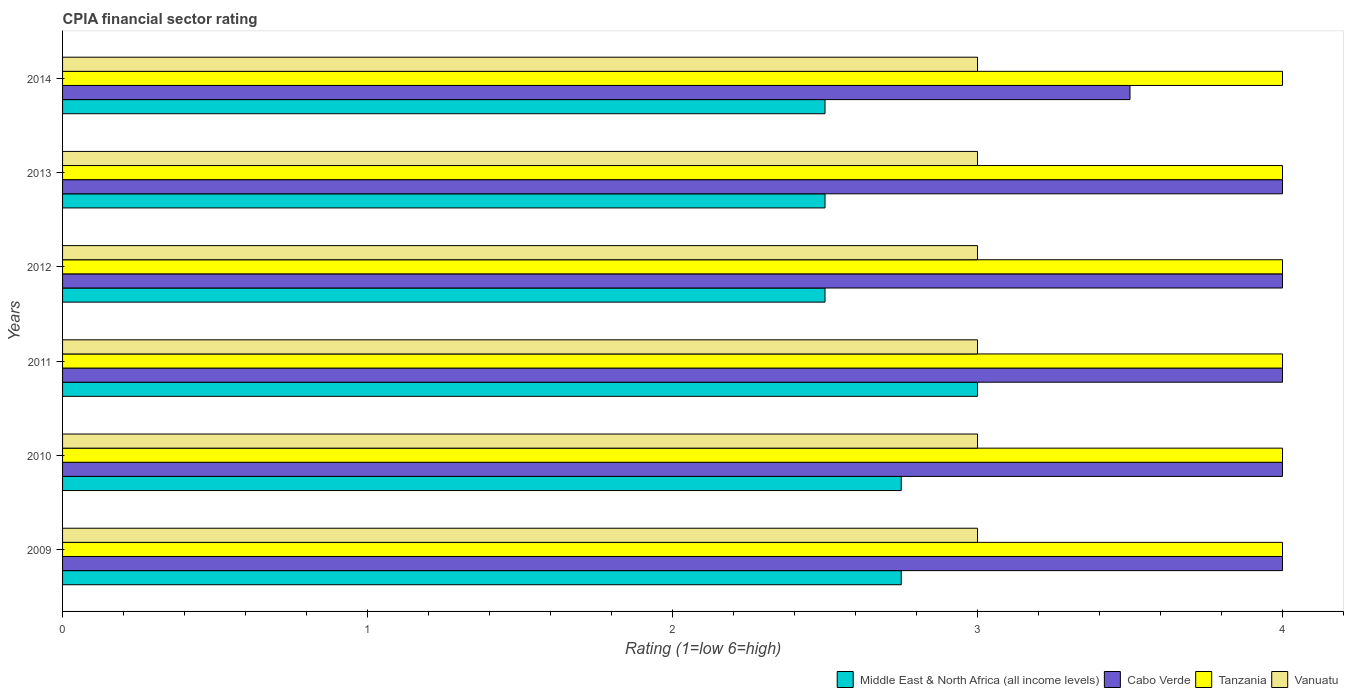Are the number of bars per tick equal to the number of legend labels?
Provide a short and direct response. Yes. How many bars are there on the 2nd tick from the bottom?
Provide a short and direct response. 4. What is the label of the 2nd group of bars from the top?
Offer a very short reply. 2013. Across all years, what is the maximum CPIA rating in Tanzania?
Your answer should be very brief. 4. In which year was the CPIA rating in Middle East & North Africa (all income levels) maximum?
Your answer should be very brief. 2011. What is the total CPIA rating in Tanzania in the graph?
Your response must be concise. 24. What is the average CPIA rating in Middle East & North Africa (all income levels) per year?
Give a very brief answer. 2.67. In the year 2009, what is the difference between the CPIA rating in Vanuatu and CPIA rating in Tanzania?
Your response must be concise. -1. Is the CPIA rating in Middle East & North Africa (all income levels) in 2011 less than that in 2013?
Provide a short and direct response. No. What is the difference between the highest and the lowest CPIA rating in Tanzania?
Make the answer very short. 0. What does the 2nd bar from the top in 2013 represents?
Offer a terse response. Tanzania. What does the 1st bar from the bottom in 2011 represents?
Ensure brevity in your answer.  Middle East & North Africa (all income levels). How many years are there in the graph?
Make the answer very short. 6. Are the values on the major ticks of X-axis written in scientific E-notation?
Keep it short and to the point. No. Does the graph contain any zero values?
Your answer should be compact. No. How many legend labels are there?
Provide a succinct answer. 4. How are the legend labels stacked?
Your answer should be very brief. Horizontal. What is the title of the graph?
Your response must be concise. CPIA financial sector rating. What is the label or title of the X-axis?
Make the answer very short. Rating (1=low 6=high). What is the label or title of the Y-axis?
Make the answer very short. Years. What is the Rating (1=low 6=high) of Middle East & North Africa (all income levels) in 2009?
Keep it short and to the point. 2.75. What is the Rating (1=low 6=high) of Tanzania in 2009?
Make the answer very short. 4. What is the Rating (1=low 6=high) of Vanuatu in 2009?
Provide a short and direct response. 3. What is the Rating (1=low 6=high) in Middle East & North Africa (all income levels) in 2010?
Provide a succinct answer. 2.75. What is the Rating (1=low 6=high) of Cabo Verde in 2010?
Ensure brevity in your answer.  4. What is the Rating (1=low 6=high) of Vanuatu in 2010?
Offer a terse response. 3. What is the Rating (1=low 6=high) of Cabo Verde in 2011?
Make the answer very short. 4. What is the Rating (1=low 6=high) in Tanzania in 2011?
Your answer should be very brief. 4. What is the Rating (1=low 6=high) in Vanuatu in 2011?
Provide a short and direct response. 3. What is the Rating (1=low 6=high) of Vanuatu in 2012?
Your response must be concise. 3. What is the Rating (1=low 6=high) in Middle East & North Africa (all income levels) in 2013?
Give a very brief answer. 2.5. What is the Rating (1=low 6=high) in Cabo Verde in 2013?
Ensure brevity in your answer.  4. Across all years, what is the maximum Rating (1=low 6=high) of Middle East & North Africa (all income levels)?
Offer a very short reply. 3. Across all years, what is the maximum Rating (1=low 6=high) of Cabo Verde?
Provide a succinct answer. 4. Across all years, what is the maximum Rating (1=low 6=high) in Tanzania?
Your answer should be very brief. 4. Across all years, what is the maximum Rating (1=low 6=high) in Vanuatu?
Your answer should be compact. 3. Across all years, what is the minimum Rating (1=low 6=high) of Cabo Verde?
Make the answer very short. 3.5. What is the total Rating (1=low 6=high) of Cabo Verde in the graph?
Give a very brief answer. 23.5. What is the difference between the Rating (1=low 6=high) of Tanzania in 2009 and that in 2011?
Offer a very short reply. 0. What is the difference between the Rating (1=low 6=high) in Middle East & North Africa (all income levels) in 2009 and that in 2012?
Your answer should be compact. 0.25. What is the difference between the Rating (1=low 6=high) of Tanzania in 2009 and that in 2012?
Make the answer very short. 0. What is the difference between the Rating (1=low 6=high) of Vanuatu in 2009 and that in 2012?
Make the answer very short. 0. What is the difference between the Rating (1=low 6=high) of Middle East & North Africa (all income levels) in 2009 and that in 2013?
Offer a terse response. 0.25. What is the difference between the Rating (1=low 6=high) of Vanuatu in 2009 and that in 2013?
Provide a short and direct response. 0. What is the difference between the Rating (1=low 6=high) in Cabo Verde in 2009 and that in 2014?
Offer a very short reply. 0.5. What is the difference between the Rating (1=low 6=high) of Vanuatu in 2009 and that in 2014?
Your answer should be very brief. 0. What is the difference between the Rating (1=low 6=high) in Middle East & North Africa (all income levels) in 2010 and that in 2011?
Offer a very short reply. -0.25. What is the difference between the Rating (1=low 6=high) in Vanuatu in 2010 and that in 2011?
Your response must be concise. 0. What is the difference between the Rating (1=low 6=high) of Middle East & North Africa (all income levels) in 2010 and that in 2012?
Ensure brevity in your answer.  0.25. What is the difference between the Rating (1=low 6=high) of Cabo Verde in 2010 and that in 2012?
Give a very brief answer. 0. What is the difference between the Rating (1=low 6=high) of Vanuatu in 2010 and that in 2012?
Provide a short and direct response. 0. What is the difference between the Rating (1=low 6=high) in Middle East & North Africa (all income levels) in 2010 and that in 2013?
Provide a short and direct response. 0.25. What is the difference between the Rating (1=low 6=high) of Tanzania in 2010 and that in 2013?
Keep it short and to the point. 0. What is the difference between the Rating (1=low 6=high) in Tanzania in 2010 and that in 2014?
Offer a very short reply. 0. What is the difference between the Rating (1=low 6=high) in Middle East & North Africa (all income levels) in 2011 and that in 2012?
Offer a terse response. 0.5. What is the difference between the Rating (1=low 6=high) in Vanuatu in 2011 and that in 2012?
Offer a terse response. 0. What is the difference between the Rating (1=low 6=high) of Middle East & North Africa (all income levels) in 2011 and that in 2013?
Provide a succinct answer. 0.5. What is the difference between the Rating (1=low 6=high) in Cabo Verde in 2011 and that in 2013?
Give a very brief answer. 0. What is the difference between the Rating (1=low 6=high) in Tanzania in 2011 and that in 2013?
Your answer should be compact. 0. What is the difference between the Rating (1=low 6=high) in Vanuatu in 2011 and that in 2014?
Offer a terse response. 0. What is the difference between the Rating (1=low 6=high) in Middle East & North Africa (all income levels) in 2012 and that in 2013?
Provide a succinct answer. 0. What is the difference between the Rating (1=low 6=high) of Cabo Verde in 2012 and that in 2013?
Make the answer very short. 0. What is the difference between the Rating (1=low 6=high) of Middle East & North Africa (all income levels) in 2012 and that in 2014?
Ensure brevity in your answer.  0. What is the difference between the Rating (1=low 6=high) of Vanuatu in 2013 and that in 2014?
Your answer should be very brief. 0. What is the difference between the Rating (1=low 6=high) in Middle East & North Africa (all income levels) in 2009 and the Rating (1=low 6=high) in Cabo Verde in 2010?
Give a very brief answer. -1.25. What is the difference between the Rating (1=low 6=high) in Middle East & North Africa (all income levels) in 2009 and the Rating (1=low 6=high) in Tanzania in 2010?
Your answer should be compact. -1.25. What is the difference between the Rating (1=low 6=high) in Middle East & North Africa (all income levels) in 2009 and the Rating (1=low 6=high) in Vanuatu in 2010?
Provide a short and direct response. -0.25. What is the difference between the Rating (1=low 6=high) of Cabo Verde in 2009 and the Rating (1=low 6=high) of Tanzania in 2010?
Provide a succinct answer. 0. What is the difference between the Rating (1=low 6=high) of Middle East & North Africa (all income levels) in 2009 and the Rating (1=low 6=high) of Cabo Verde in 2011?
Keep it short and to the point. -1.25. What is the difference between the Rating (1=low 6=high) of Middle East & North Africa (all income levels) in 2009 and the Rating (1=low 6=high) of Tanzania in 2011?
Give a very brief answer. -1.25. What is the difference between the Rating (1=low 6=high) in Cabo Verde in 2009 and the Rating (1=low 6=high) in Tanzania in 2011?
Ensure brevity in your answer.  0. What is the difference between the Rating (1=low 6=high) of Cabo Verde in 2009 and the Rating (1=low 6=high) of Vanuatu in 2011?
Make the answer very short. 1. What is the difference between the Rating (1=low 6=high) in Tanzania in 2009 and the Rating (1=low 6=high) in Vanuatu in 2011?
Keep it short and to the point. 1. What is the difference between the Rating (1=low 6=high) of Middle East & North Africa (all income levels) in 2009 and the Rating (1=low 6=high) of Cabo Verde in 2012?
Give a very brief answer. -1.25. What is the difference between the Rating (1=low 6=high) in Middle East & North Africa (all income levels) in 2009 and the Rating (1=low 6=high) in Tanzania in 2012?
Give a very brief answer. -1.25. What is the difference between the Rating (1=low 6=high) of Middle East & North Africa (all income levels) in 2009 and the Rating (1=low 6=high) of Vanuatu in 2012?
Provide a succinct answer. -0.25. What is the difference between the Rating (1=low 6=high) in Cabo Verde in 2009 and the Rating (1=low 6=high) in Vanuatu in 2012?
Give a very brief answer. 1. What is the difference between the Rating (1=low 6=high) of Middle East & North Africa (all income levels) in 2009 and the Rating (1=low 6=high) of Cabo Verde in 2013?
Your response must be concise. -1.25. What is the difference between the Rating (1=low 6=high) of Middle East & North Africa (all income levels) in 2009 and the Rating (1=low 6=high) of Tanzania in 2013?
Offer a very short reply. -1.25. What is the difference between the Rating (1=low 6=high) of Middle East & North Africa (all income levels) in 2009 and the Rating (1=low 6=high) of Vanuatu in 2013?
Give a very brief answer. -0.25. What is the difference between the Rating (1=low 6=high) in Cabo Verde in 2009 and the Rating (1=low 6=high) in Tanzania in 2013?
Your answer should be very brief. 0. What is the difference between the Rating (1=low 6=high) of Middle East & North Africa (all income levels) in 2009 and the Rating (1=low 6=high) of Cabo Verde in 2014?
Your response must be concise. -0.75. What is the difference between the Rating (1=low 6=high) of Middle East & North Africa (all income levels) in 2009 and the Rating (1=low 6=high) of Tanzania in 2014?
Offer a very short reply. -1.25. What is the difference between the Rating (1=low 6=high) in Cabo Verde in 2009 and the Rating (1=low 6=high) in Vanuatu in 2014?
Provide a succinct answer. 1. What is the difference between the Rating (1=low 6=high) of Middle East & North Africa (all income levels) in 2010 and the Rating (1=low 6=high) of Cabo Verde in 2011?
Keep it short and to the point. -1.25. What is the difference between the Rating (1=low 6=high) of Middle East & North Africa (all income levels) in 2010 and the Rating (1=low 6=high) of Tanzania in 2011?
Provide a succinct answer. -1.25. What is the difference between the Rating (1=low 6=high) of Middle East & North Africa (all income levels) in 2010 and the Rating (1=low 6=high) of Vanuatu in 2011?
Make the answer very short. -0.25. What is the difference between the Rating (1=low 6=high) of Cabo Verde in 2010 and the Rating (1=low 6=high) of Tanzania in 2011?
Provide a succinct answer. 0. What is the difference between the Rating (1=low 6=high) of Cabo Verde in 2010 and the Rating (1=low 6=high) of Vanuatu in 2011?
Make the answer very short. 1. What is the difference between the Rating (1=low 6=high) of Middle East & North Africa (all income levels) in 2010 and the Rating (1=low 6=high) of Cabo Verde in 2012?
Provide a short and direct response. -1.25. What is the difference between the Rating (1=low 6=high) of Middle East & North Africa (all income levels) in 2010 and the Rating (1=low 6=high) of Tanzania in 2012?
Your answer should be compact. -1.25. What is the difference between the Rating (1=low 6=high) in Cabo Verde in 2010 and the Rating (1=low 6=high) in Tanzania in 2012?
Make the answer very short. 0. What is the difference between the Rating (1=low 6=high) in Tanzania in 2010 and the Rating (1=low 6=high) in Vanuatu in 2012?
Ensure brevity in your answer.  1. What is the difference between the Rating (1=low 6=high) of Middle East & North Africa (all income levels) in 2010 and the Rating (1=low 6=high) of Cabo Verde in 2013?
Give a very brief answer. -1.25. What is the difference between the Rating (1=low 6=high) of Middle East & North Africa (all income levels) in 2010 and the Rating (1=low 6=high) of Tanzania in 2013?
Give a very brief answer. -1.25. What is the difference between the Rating (1=low 6=high) in Middle East & North Africa (all income levels) in 2010 and the Rating (1=low 6=high) in Vanuatu in 2013?
Your answer should be compact. -0.25. What is the difference between the Rating (1=low 6=high) in Cabo Verde in 2010 and the Rating (1=low 6=high) in Tanzania in 2013?
Provide a succinct answer. 0. What is the difference between the Rating (1=low 6=high) of Cabo Verde in 2010 and the Rating (1=low 6=high) of Vanuatu in 2013?
Your answer should be compact. 1. What is the difference between the Rating (1=low 6=high) of Tanzania in 2010 and the Rating (1=low 6=high) of Vanuatu in 2013?
Give a very brief answer. 1. What is the difference between the Rating (1=low 6=high) of Middle East & North Africa (all income levels) in 2010 and the Rating (1=low 6=high) of Cabo Verde in 2014?
Offer a very short reply. -0.75. What is the difference between the Rating (1=low 6=high) of Middle East & North Africa (all income levels) in 2010 and the Rating (1=low 6=high) of Tanzania in 2014?
Your response must be concise. -1.25. What is the difference between the Rating (1=low 6=high) in Cabo Verde in 2010 and the Rating (1=low 6=high) in Tanzania in 2014?
Provide a succinct answer. 0. What is the difference between the Rating (1=low 6=high) of Cabo Verde in 2010 and the Rating (1=low 6=high) of Vanuatu in 2014?
Provide a succinct answer. 1. What is the difference between the Rating (1=low 6=high) of Tanzania in 2010 and the Rating (1=low 6=high) of Vanuatu in 2014?
Your answer should be very brief. 1. What is the difference between the Rating (1=low 6=high) of Middle East & North Africa (all income levels) in 2011 and the Rating (1=low 6=high) of Cabo Verde in 2012?
Offer a terse response. -1. What is the difference between the Rating (1=low 6=high) in Middle East & North Africa (all income levels) in 2011 and the Rating (1=low 6=high) in Tanzania in 2012?
Your response must be concise. -1. What is the difference between the Rating (1=low 6=high) in Middle East & North Africa (all income levels) in 2011 and the Rating (1=low 6=high) in Vanuatu in 2012?
Keep it short and to the point. 0. What is the difference between the Rating (1=low 6=high) of Cabo Verde in 2011 and the Rating (1=low 6=high) of Vanuatu in 2012?
Provide a succinct answer. 1. What is the difference between the Rating (1=low 6=high) in Tanzania in 2011 and the Rating (1=low 6=high) in Vanuatu in 2012?
Offer a terse response. 1. What is the difference between the Rating (1=low 6=high) of Middle East & North Africa (all income levels) in 2011 and the Rating (1=low 6=high) of Cabo Verde in 2013?
Provide a short and direct response. -1. What is the difference between the Rating (1=low 6=high) in Middle East & North Africa (all income levels) in 2011 and the Rating (1=low 6=high) in Tanzania in 2013?
Your answer should be compact. -1. What is the difference between the Rating (1=low 6=high) in Cabo Verde in 2011 and the Rating (1=low 6=high) in Tanzania in 2013?
Give a very brief answer. 0. What is the difference between the Rating (1=low 6=high) in Middle East & North Africa (all income levels) in 2011 and the Rating (1=low 6=high) in Cabo Verde in 2014?
Ensure brevity in your answer.  -0.5. What is the difference between the Rating (1=low 6=high) of Middle East & North Africa (all income levels) in 2011 and the Rating (1=low 6=high) of Tanzania in 2014?
Ensure brevity in your answer.  -1. What is the difference between the Rating (1=low 6=high) of Cabo Verde in 2011 and the Rating (1=low 6=high) of Vanuatu in 2014?
Ensure brevity in your answer.  1. What is the difference between the Rating (1=low 6=high) in Tanzania in 2011 and the Rating (1=low 6=high) in Vanuatu in 2014?
Your answer should be compact. 1. What is the difference between the Rating (1=low 6=high) in Middle East & North Africa (all income levels) in 2012 and the Rating (1=low 6=high) in Cabo Verde in 2013?
Your answer should be very brief. -1.5. What is the difference between the Rating (1=low 6=high) of Middle East & North Africa (all income levels) in 2012 and the Rating (1=low 6=high) of Vanuatu in 2013?
Your response must be concise. -0.5. What is the difference between the Rating (1=low 6=high) in Tanzania in 2012 and the Rating (1=low 6=high) in Vanuatu in 2013?
Your response must be concise. 1. What is the difference between the Rating (1=low 6=high) of Middle East & North Africa (all income levels) in 2012 and the Rating (1=low 6=high) of Cabo Verde in 2014?
Your answer should be compact. -1. What is the difference between the Rating (1=low 6=high) in Middle East & North Africa (all income levels) in 2012 and the Rating (1=low 6=high) in Tanzania in 2014?
Your answer should be compact. -1.5. What is the difference between the Rating (1=low 6=high) in Cabo Verde in 2012 and the Rating (1=low 6=high) in Tanzania in 2014?
Provide a succinct answer. 0. What is the difference between the Rating (1=low 6=high) in Cabo Verde in 2012 and the Rating (1=low 6=high) in Vanuatu in 2014?
Your response must be concise. 1. What is the difference between the Rating (1=low 6=high) of Tanzania in 2012 and the Rating (1=low 6=high) of Vanuatu in 2014?
Your response must be concise. 1. What is the difference between the Rating (1=low 6=high) in Middle East & North Africa (all income levels) in 2013 and the Rating (1=low 6=high) in Cabo Verde in 2014?
Offer a terse response. -1. What is the difference between the Rating (1=low 6=high) of Cabo Verde in 2013 and the Rating (1=low 6=high) of Tanzania in 2014?
Offer a very short reply. 0. What is the difference between the Rating (1=low 6=high) of Tanzania in 2013 and the Rating (1=low 6=high) of Vanuatu in 2014?
Provide a succinct answer. 1. What is the average Rating (1=low 6=high) of Middle East & North Africa (all income levels) per year?
Ensure brevity in your answer.  2.67. What is the average Rating (1=low 6=high) of Cabo Verde per year?
Provide a short and direct response. 3.92. What is the average Rating (1=low 6=high) of Tanzania per year?
Provide a succinct answer. 4. In the year 2009, what is the difference between the Rating (1=low 6=high) in Middle East & North Africa (all income levels) and Rating (1=low 6=high) in Cabo Verde?
Keep it short and to the point. -1.25. In the year 2009, what is the difference between the Rating (1=low 6=high) of Middle East & North Africa (all income levels) and Rating (1=low 6=high) of Tanzania?
Make the answer very short. -1.25. In the year 2010, what is the difference between the Rating (1=low 6=high) in Middle East & North Africa (all income levels) and Rating (1=low 6=high) in Cabo Verde?
Ensure brevity in your answer.  -1.25. In the year 2010, what is the difference between the Rating (1=low 6=high) of Middle East & North Africa (all income levels) and Rating (1=low 6=high) of Tanzania?
Offer a very short reply. -1.25. In the year 2010, what is the difference between the Rating (1=low 6=high) in Middle East & North Africa (all income levels) and Rating (1=low 6=high) in Vanuatu?
Your response must be concise. -0.25. In the year 2010, what is the difference between the Rating (1=low 6=high) in Cabo Verde and Rating (1=low 6=high) in Tanzania?
Offer a terse response. 0. In the year 2010, what is the difference between the Rating (1=low 6=high) of Tanzania and Rating (1=low 6=high) of Vanuatu?
Your answer should be compact. 1. In the year 2011, what is the difference between the Rating (1=low 6=high) in Middle East & North Africa (all income levels) and Rating (1=low 6=high) in Vanuatu?
Your response must be concise. 0. In the year 2011, what is the difference between the Rating (1=low 6=high) in Cabo Verde and Rating (1=low 6=high) in Vanuatu?
Ensure brevity in your answer.  1. In the year 2013, what is the difference between the Rating (1=low 6=high) of Middle East & North Africa (all income levels) and Rating (1=low 6=high) of Cabo Verde?
Your response must be concise. -1.5. In the year 2013, what is the difference between the Rating (1=low 6=high) of Middle East & North Africa (all income levels) and Rating (1=low 6=high) of Tanzania?
Offer a terse response. -1.5. In the year 2013, what is the difference between the Rating (1=low 6=high) of Middle East & North Africa (all income levels) and Rating (1=low 6=high) of Vanuatu?
Provide a succinct answer. -0.5. In the year 2014, what is the difference between the Rating (1=low 6=high) in Middle East & North Africa (all income levels) and Rating (1=low 6=high) in Vanuatu?
Offer a very short reply. -0.5. In the year 2014, what is the difference between the Rating (1=low 6=high) of Cabo Verde and Rating (1=low 6=high) of Tanzania?
Make the answer very short. -0.5. In the year 2014, what is the difference between the Rating (1=low 6=high) in Tanzania and Rating (1=low 6=high) in Vanuatu?
Your response must be concise. 1. What is the ratio of the Rating (1=low 6=high) in Middle East & North Africa (all income levels) in 2009 to that in 2010?
Your answer should be compact. 1. What is the ratio of the Rating (1=low 6=high) in Tanzania in 2009 to that in 2010?
Provide a succinct answer. 1. What is the ratio of the Rating (1=low 6=high) of Middle East & North Africa (all income levels) in 2009 to that in 2011?
Keep it short and to the point. 0.92. What is the ratio of the Rating (1=low 6=high) of Cabo Verde in 2009 to that in 2011?
Your answer should be compact. 1. What is the ratio of the Rating (1=low 6=high) in Tanzania in 2009 to that in 2011?
Your answer should be compact. 1. What is the ratio of the Rating (1=low 6=high) of Vanuatu in 2009 to that in 2011?
Make the answer very short. 1. What is the ratio of the Rating (1=low 6=high) of Cabo Verde in 2009 to that in 2012?
Ensure brevity in your answer.  1. What is the ratio of the Rating (1=low 6=high) in Vanuatu in 2009 to that in 2012?
Keep it short and to the point. 1. What is the ratio of the Rating (1=low 6=high) in Cabo Verde in 2009 to that in 2013?
Your answer should be very brief. 1. What is the ratio of the Rating (1=low 6=high) of Middle East & North Africa (all income levels) in 2009 to that in 2014?
Your answer should be very brief. 1.1. What is the ratio of the Rating (1=low 6=high) of Cabo Verde in 2009 to that in 2014?
Give a very brief answer. 1.14. What is the ratio of the Rating (1=low 6=high) in Tanzania in 2009 to that in 2014?
Your response must be concise. 1. What is the ratio of the Rating (1=low 6=high) of Vanuatu in 2009 to that in 2014?
Make the answer very short. 1. What is the ratio of the Rating (1=low 6=high) of Middle East & North Africa (all income levels) in 2010 to that in 2011?
Your response must be concise. 0.92. What is the ratio of the Rating (1=low 6=high) of Cabo Verde in 2010 to that in 2011?
Your response must be concise. 1. What is the ratio of the Rating (1=low 6=high) in Tanzania in 2010 to that in 2011?
Give a very brief answer. 1. What is the ratio of the Rating (1=low 6=high) in Vanuatu in 2010 to that in 2011?
Offer a very short reply. 1. What is the ratio of the Rating (1=low 6=high) of Middle East & North Africa (all income levels) in 2010 to that in 2013?
Offer a very short reply. 1.1. What is the ratio of the Rating (1=low 6=high) of Cabo Verde in 2010 to that in 2013?
Provide a succinct answer. 1. What is the ratio of the Rating (1=low 6=high) in Tanzania in 2010 to that in 2013?
Give a very brief answer. 1. What is the ratio of the Rating (1=low 6=high) of Vanuatu in 2010 to that in 2013?
Offer a very short reply. 1. What is the ratio of the Rating (1=low 6=high) of Middle East & North Africa (all income levels) in 2010 to that in 2014?
Your answer should be compact. 1.1. What is the ratio of the Rating (1=low 6=high) of Vanuatu in 2010 to that in 2014?
Provide a short and direct response. 1. What is the ratio of the Rating (1=low 6=high) in Middle East & North Africa (all income levels) in 2011 to that in 2012?
Your response must be concise. 1.2. What is the ratio of the Rating (1=low 6=high) of Cabo Verde in 2011 to that in 2012?
Provide a short and direct response. 1. What is the ratio of the Rating (1=low 6=high) in Middle East & North Africa (all income levels) in 2011 to that in 2013?
Make the answer very short. 1.2. What is the ratio of the Rating (1=low 6=high) of Cabo Verde in 2011 to that in 2013?
Give a very brief answer. 1. What is the ratio of the Rating (1=low 6=high) in Cabo Verde in 2011 to that in 2014?
Keep it short and to the point. 1.14. What is the ratio of the Rating (1=low 6=high) in Vanuatu in 2011 to that in 2014?
Offer a very short reply. 1. What is the ratio of the Rating (1=low 6=high) in Tanzania in 2012 to that in 2013?
Your response must be concise. 1. What is the ratio of the Rating (1=low 6=high) of Vanuatu in 2012 to that in 2013?
Give a very brief answer. 1. What is the ratio of the Rating (1=low 6=high) in Tanzania in 2012 to that in 2014?
Your answer should be compact. 1. What is the ratio of the Rating (1=low 6=high) in Cabo Verde in 2013 to that in 2014?
Provide a short and direct response. 1.14. What is the ratio of the Rating (1=low 6=high) of Tanzania in 2013 to that in 2014?
Make the answer very short. 1. What is the ratio of the Rating (1=low 6=high) of Vanuatu in 2013 to that in 2014?
Your answer should be very brief. 1. What is the difference between the highest and the second highest Rating (1=low 6=high) of Middle East & North Africa (all income levels)?
Provide a short and direct response. 0.25. What is the difference between the highest and the second highest Rating (1=low 6=high) in Cabo Verde?
Make the answer very short. 0. What is the difference between the highest and the lowest Rating (1=low 6=high) of Middle East & North Africa (all income levels)?
Your answer should be very brief. 0.5. What is the difference between the highest and the lowest Rating (1=low 6=high) in Cabo Verde?
Make the answer very short. 0.5. What is the difference between the highest and the lowest Rating (1=low 6=high) of Tanzania?
Your response must be concise. 0. What is the difference between the highest and the lowest Rating (1=low 6=high) of Vanuatu?
Your answer should be compact. 0. 